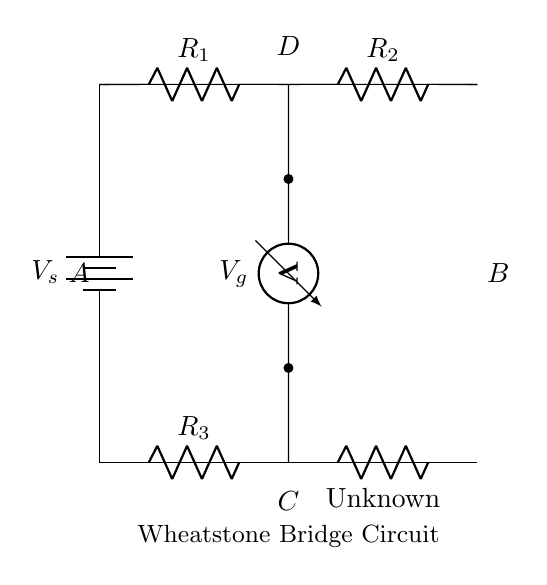What is the type of circuit represented? The diagram represents a Wheatstone bridge, which is specifically designed for measuring unknown resistances by balancing two legs of a bridge circuit.
Answer: Wheatstone bridge What are the resistors in the circuit? The circuit contains four resistors, labeled R1, R2, R3, and Rx (the unknown resistor), which are arranged in a bridge configuration.
Answer: R1, R2, R3, Rx What is the purpose of the voltmeter in the circuit? The voltmeter is connected between points C and D in the circuit to measure the potential difference across the bridge, which helps detect the balance condition of the circuit.
Answer: Measure voltage When is the bridge considered balanced? The bridge is balanced when the potential difference (voltage) across the voltmeter is zero, indicating equal resistance ratios in both legs of the bridge.
Answer: Zero voltage What determines the value of the unknown resistor Rx? The value of the unknown resistor Rx can be determined using the known resistances R1, R2, and R3 when the bridge is balanced, following the relationship R1/R2 = R3/Rx.
Answer: Known resistances What is the significance of the battery voltage Vs? The voltage Vs provides the necessary current in the circuit, allowing for a measurement across the voltmeter to determine the balance and hence calculate the unknown resistance.
Answer: Supply voltage What happens if the bridge is not balanced? If the bridge is not balanced, the voltmeter will indicate a non-zero voltage, and adjustments need to be made to the known resistors until balance is achieved for accurate resistance measurement.
Answer: Non-zero voltage 